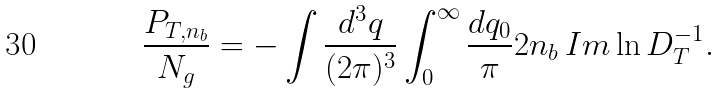<formula> <loc_0><loc_0><loc_500><loc_500>\frac { P _ { T , n _ { b } } } { N _ { g } } = - \int \frac { d ^ { 3 } q } { ( 2 \pi ) ^ { 3 } } \int _ { 0 } ^ { \infty } \frac { d q _ { 0 } } { \pi } 2 n _ { b } \, I m \ln D ^ { - 1 } _ { T } .</formula> 